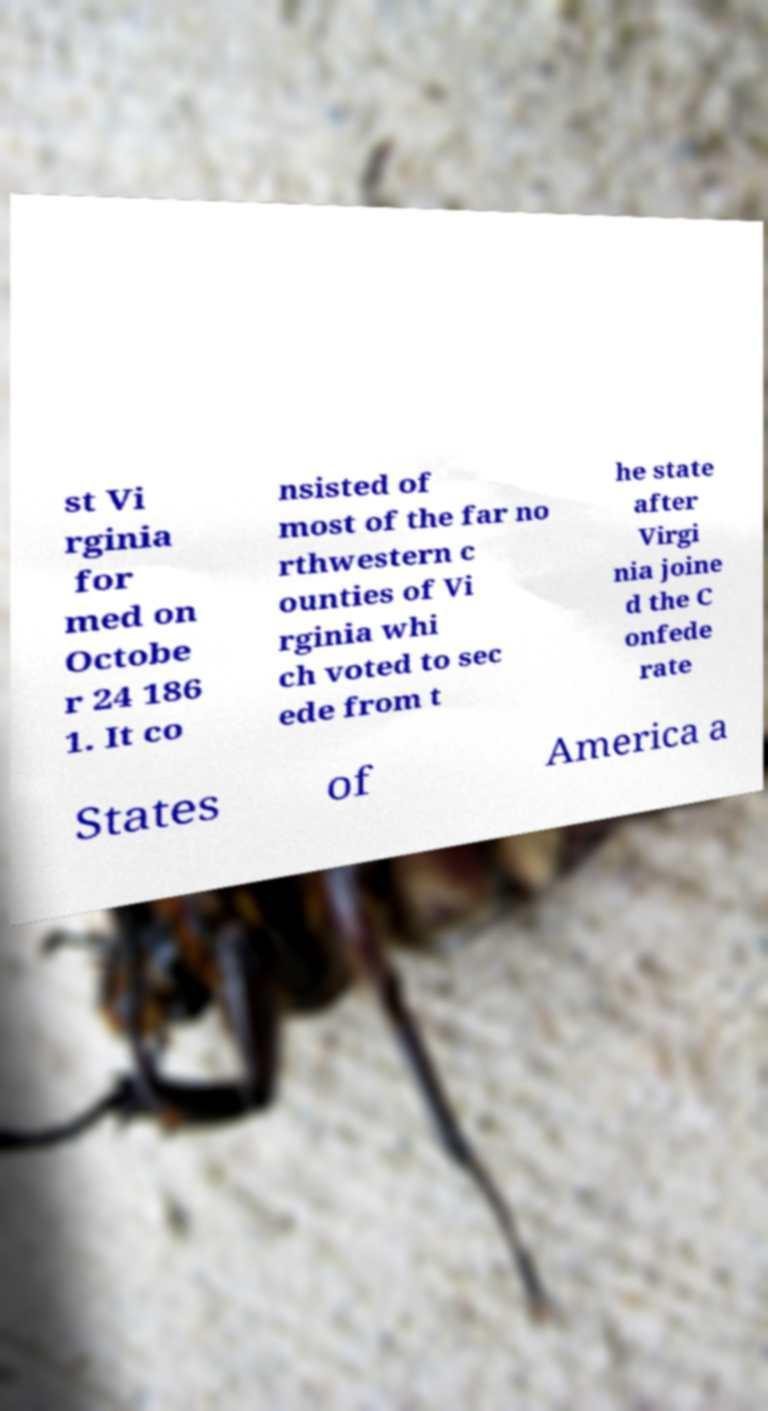There's text embedded in this image that I need extracted. Can you transcribe it verbatim? st Vi rginia for med on Octobe r 24 186 1. It co nsisted of most of the far no rthwestern c ounties of Vi rginia whi ch voted to sec ede from t he state after Virgi nia joine d the C onfede rate States of America a 